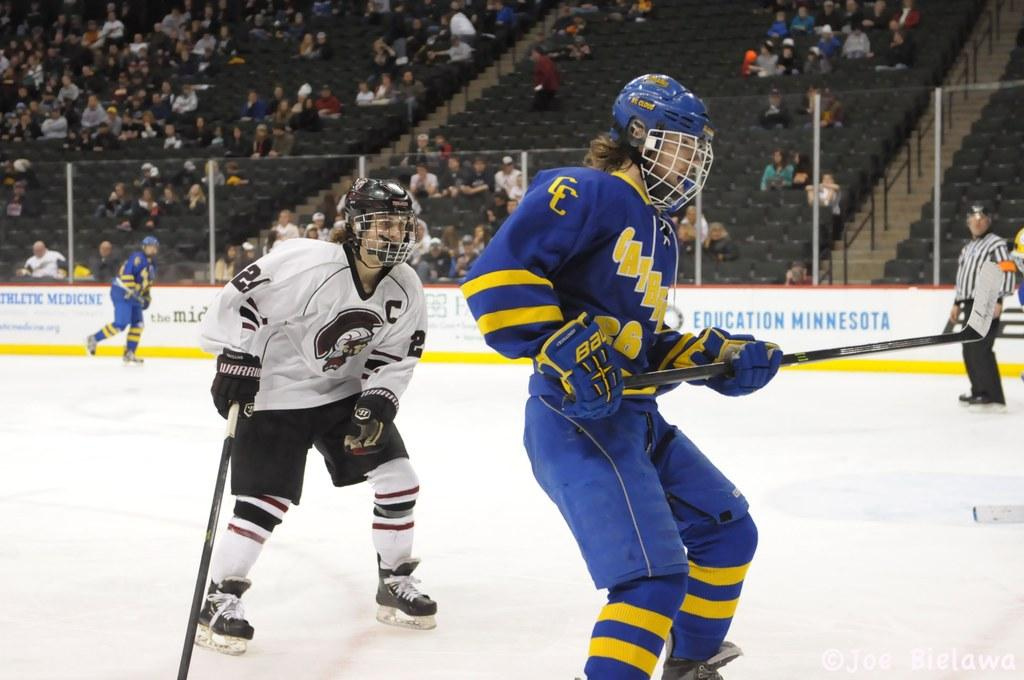What type of sports facility is shown in the image? There is an ice hockey stadium in the image. What activity is taking place in the stadium? Players are playing a game in the stadium. What can be seen in the background of the image? There is a fencing in the background of the image. What are the people behind the fencing doing? People are sitting on chairs behind the fencing. Where are the children playing with flowers in the image? There are no children or flowers present in the image; it features an ice hockey stadium with players on the ice. 